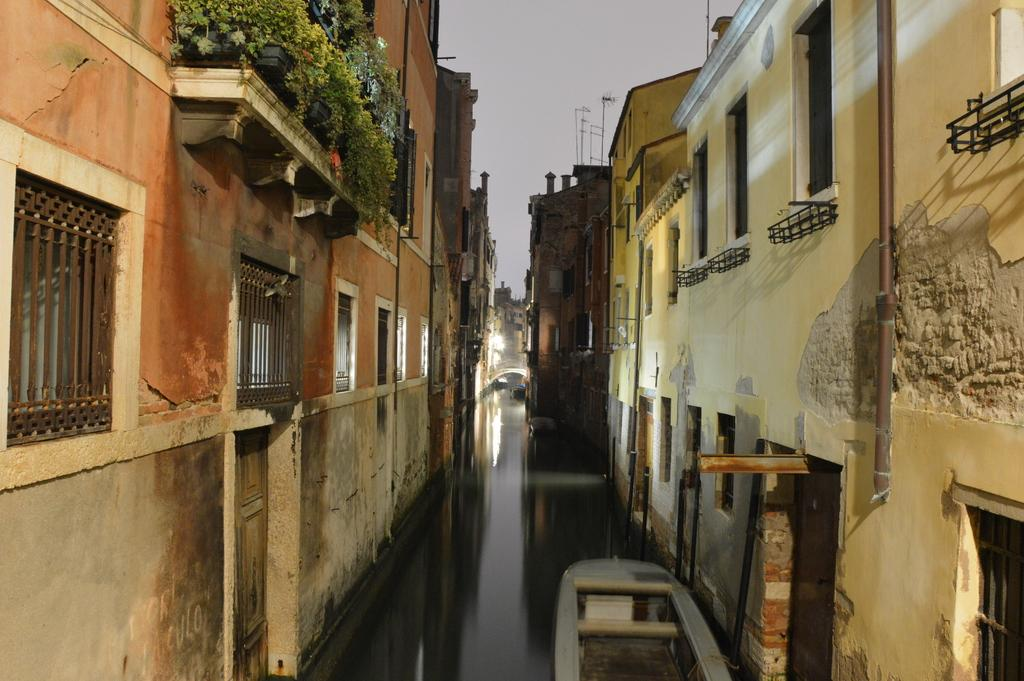What type of structures can be seen in the image? There are buildings in the image. What architectural features are present on the buildings? There are windows visible on the buildings. What objects are placed near the buildings? There are flower pots in the image. What vertical object is present in the image? There is a pole in the image. What natural element is visible in the image? There is water visible in the image. What type of vehicle is present in the water? There is a boat in the image. What type of barrier is present in the image? There is a wall in the image. What is the color of the sky in the image? The sky appears to be white in color. Where is the pencil located in the image? There is no pencil present in the image. What type of observation is being conducted in the image? There is no indication of an observation being conducted in the image. 